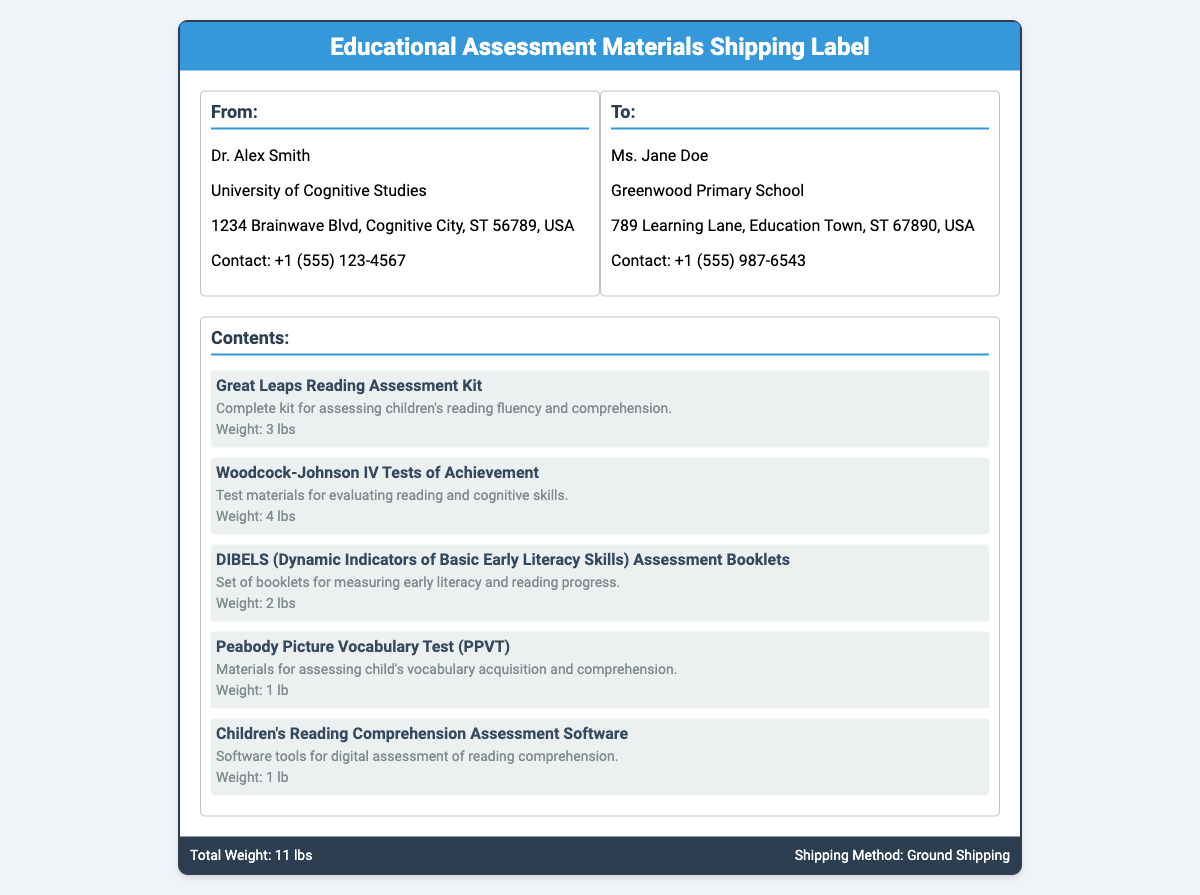What is the name of the sender? The sender's name is mentioned at the top of the "From" section in the address, which is Dr. Alex Smith.
Answer: Dr. Alex Smith What is the total weight of the shipment? The total weight is summarized at the bottom of the label in the footer, stating "Total Weight: 11 lbs."
Answer: 11 lbs Who is the recipient? The recipient's name is provided in the "To" section of the address, which is Ms. Jane Doe.
Answer: Ms. Jane Doe What is the shipping method used? The shipping method is indicated in the footer of the document as "Ground Shipping."
Answer: Ground Shipping How many items are listed in the contents? The number of items can be counted directly from the contents section, which lists five different assessment materials.
Answer: 5 What is the purpose of the Great Leaps Reading Assessment Kit? The purpose is stated in the description with the kit being for assessing children's reading fluency and comprehension.
Answer: Assessing children's reading fluency and comprehension Which item has the least weight? The weights of all listed items can be compared, and the item with the least weight is highlighted in its description as "1 lb."
Answer: 1 lb What is the first item listed in the contents? The first item in the contents section is named and described at the beginning of the list: "Great Leaps Reading Assessment Kit."
Answer: Great Leaps Reading Assessment Kit What is the contact number for the recipient? The recipient's contact information is provided in the "To" section, which shows "+1 (555) 987-6543."
Answer: +1 (555) 987-6543 